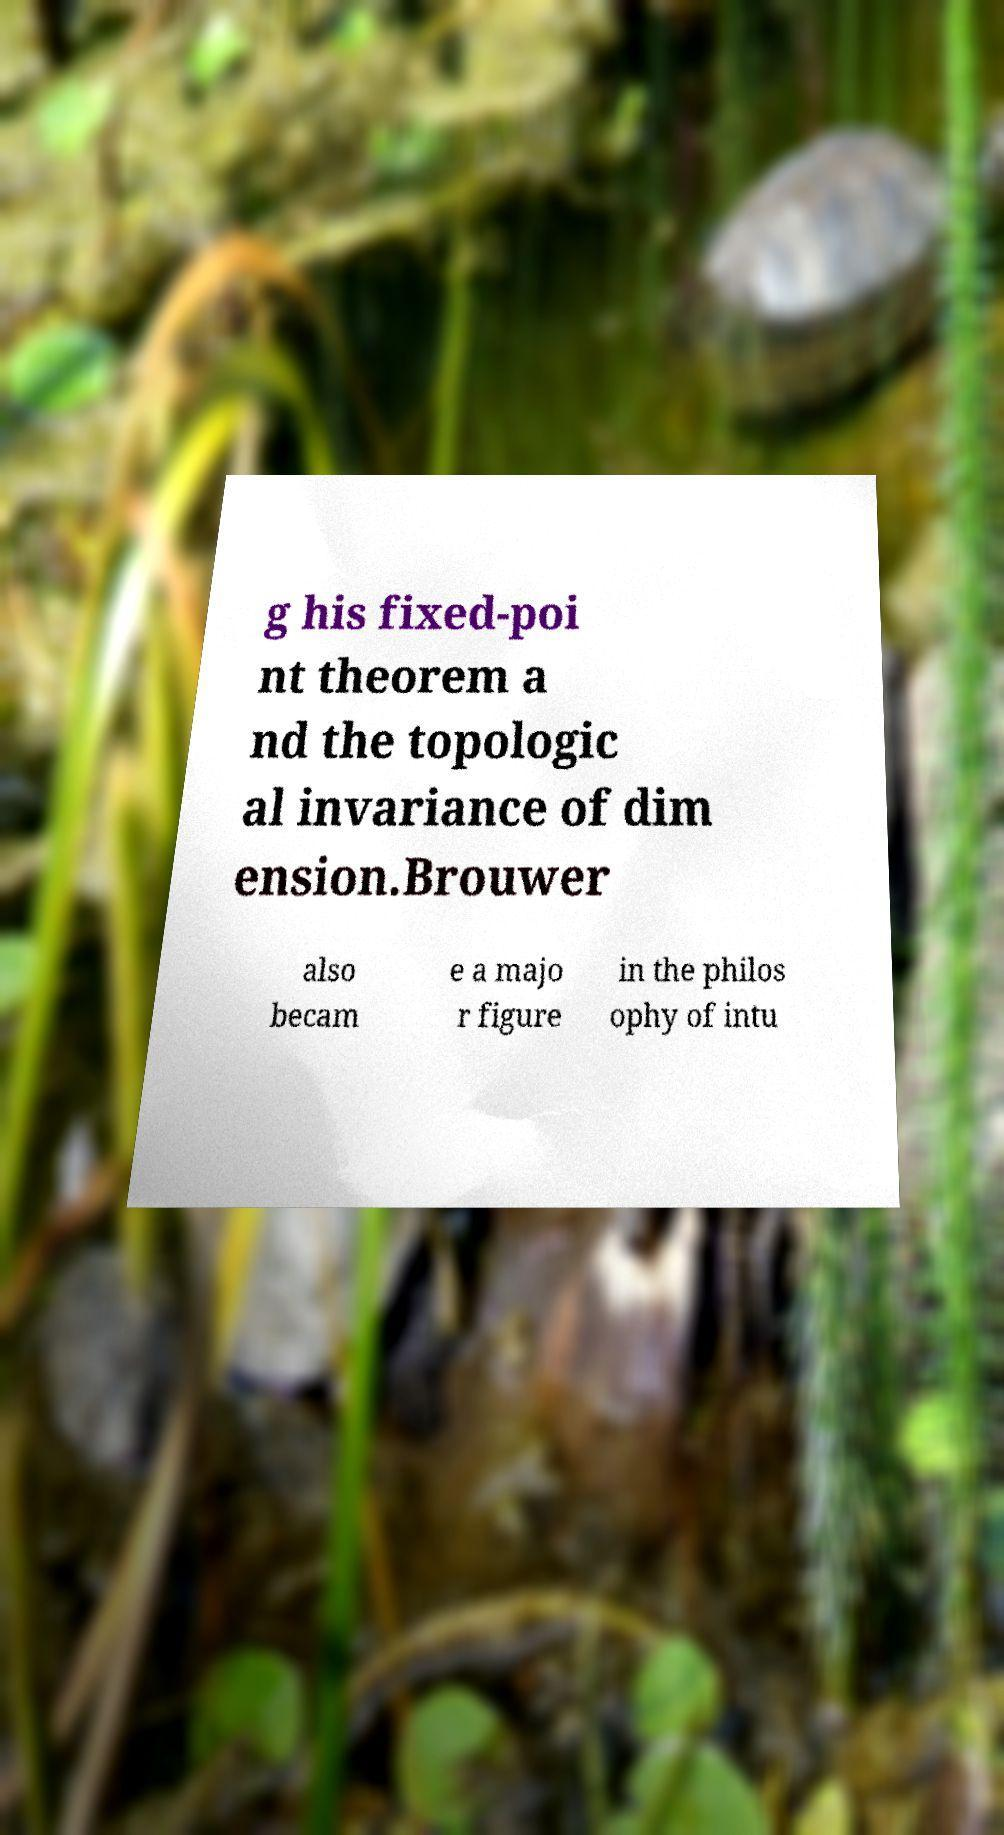Could you extract and type out the text from this image? g his fixed-poi nt theorem a nd the topologic al invariance of dim ension.Brouwer also becam e a majo r figure in the philos ophy of intu 